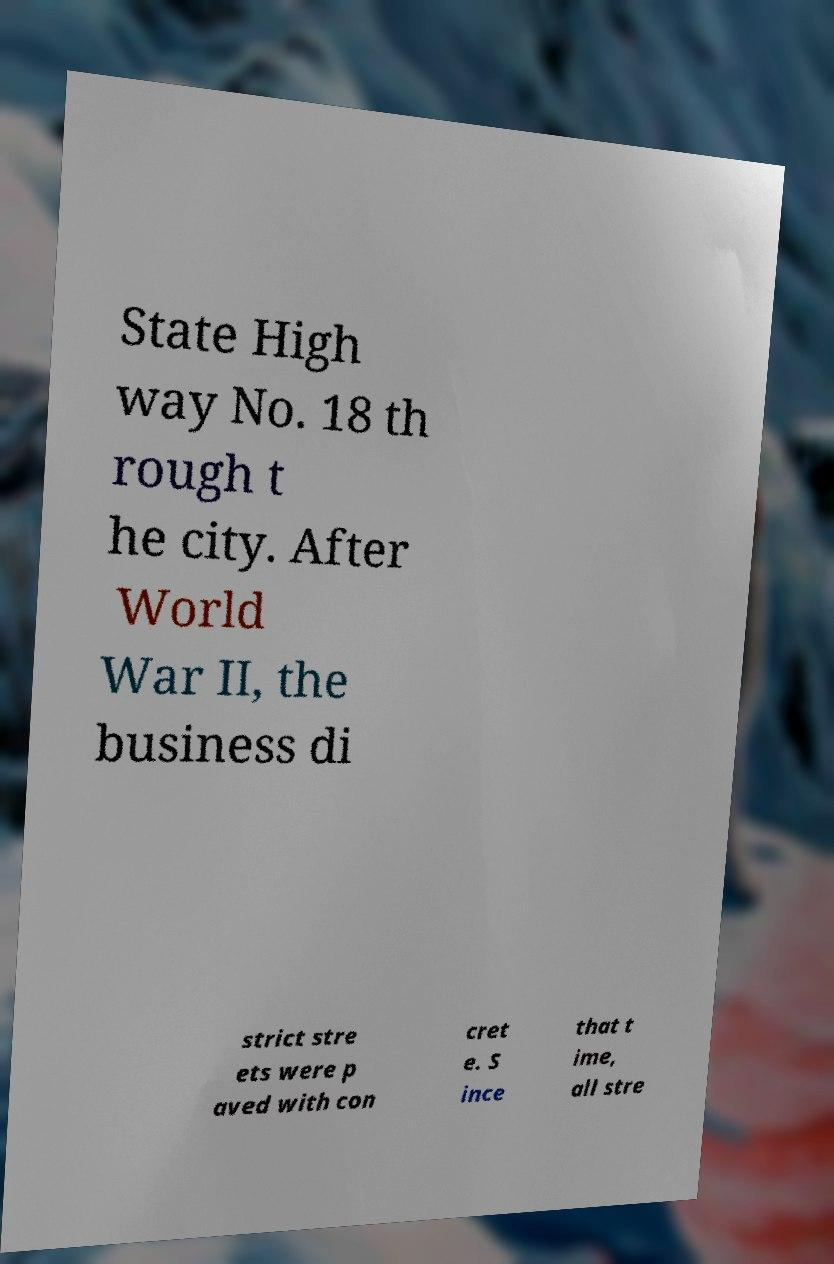Please identify and transcribe the text found in this image. State High way No. 18 th rough t he city. After World War II, the business di strict stre ets were p aved with con cret e. S ince that t ime, all stre 